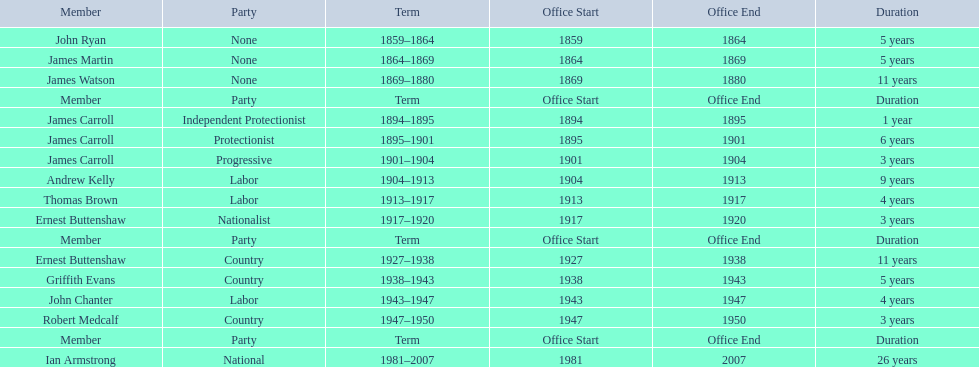Of the members of the third incarnation of the lachlan, who served the longest? Ernest Buttenshaw. 